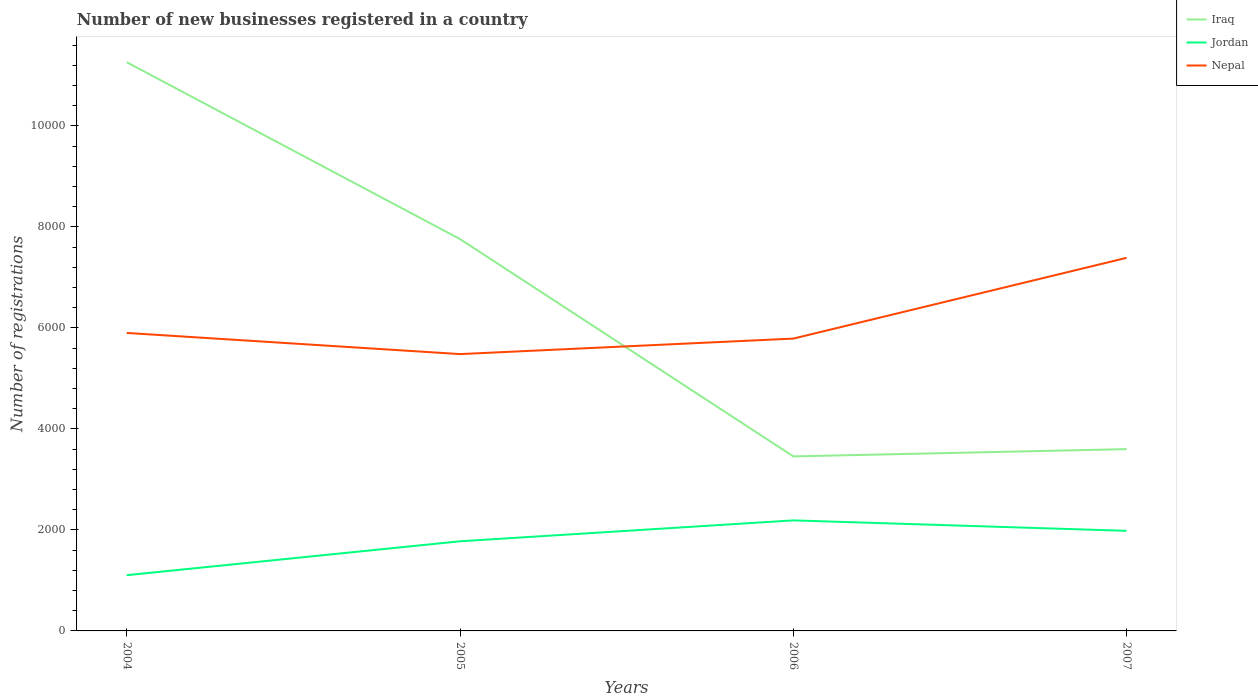Is the number of lines equal to the number of legend labels?
Provide a short and direct response. Yes. Across all years, what is the maximum number of new businesses registered in Jordan?
Provide a succinct answer. 1104. What is the total number of new businesses registered in Nepal in the graph?
Offer a very short reply. -307. What is the difference between the highest and the second highest number of new businesses registered in Nepal?
Give a very brief answer. 1906. How many years are there in the graph?
Make the answer very short. 4. What is the difference between two consecutive major ticks on the Y-axis?
Give a very brief answer. 2000. How many legend labels are there?
Provide a short and direct response. 3. What is the title of the graph?
Your answer should be very brief. Number of new businesses registered in a country. What is the label or title of the Y-axis?
Make the answer very short. Number of registrations. What is the Number of registrations in Iraq in 2004?
Your response must be concise. 1.13e+04. What is the Number of registrations of Jordan in 2004?
Provide a short and direct response. 1104. What is the Number of registrations in Nepal in 2004?
Your answer should be compact. 5901. What is the Number of registrations of Iraq in 2005?
Keep it short and to the point. 7760. What is the Number of registrations of Jordan in 2005?
Provide a short and direct response. 1775. What is the Number of registrations in Nepal in 2005?
Provide a succinct answer. 5482. What is the Number of registrations of Iraq in 2006?
Offer a very short reply. 3456. What is the Number of registrations of Jordan in 2006?
Keep it short and to the point. 2189. What is the Number of registrations of Nepal in 2006?
Your answer should be compact. 5789. What is the Number of registrations of Iraq in 2007?
Your response must be concise. 3600. What is the Number of registrations of Jordan in 2007?
Make the answer very short. 1982. What is the Number of registrations of Nepal in 2007?
Ensure brevity in your answer.  7388. Across all years, what is the maximum Number of registrations of Iraq?
Offer a terse response. 1.13e+04. Across all years, what is the maximum Number of registrations of Jordan?
Provide a short and direct response. 2189. Across all years, what is the maximum Number of registrations in Nepal?
Keep it short and to the point. 7388. Across all years, what is the minimum Number of registrations in Iraq?
Your response must be concise. 3456. Across all years, what is the minimum Number of registrations in Jordan?
Your answer should be very brief. 1104. Across all years, what is the minimum Number of registrations in Nepal?
Provide a short and direct response. 5482. What is the total Number of registrations in Iraq in the graph?
Provide a short and direct response. 2.61e+04. What is the total Number of registrations of Jordan in the graph?
Your answer should be compact. 7050. What is the total Number of registrations in Nepal in the graph?
Offer a very short reply. 2.46e+04. What is the difference between the Number of registrations of Iraq in 2004 and that in 2005?
Offer a very short reply. 3502. What is the difference between the Number of registrations of Jordan in 2004 and that in 2005?
Offer a very short reply. -671. What is the difference between the Number of registrations in Nepal in 2004 and that in 2005?
Provide a short and direct response. 419. What is the difference between the Number of registrations of Iraq in 2004 and that in 2006?
Offer a very short reply. 7806. What is the difference between the Number of registrations in Jordan in 2004 and that in 2006?
Offer a terse response. -1085. What is the difference between the Number of registrations in Nepal in 2004 and that in 2006?
Ensure brevity in your answer.  112. What is the difference between the Number of registrations in Iraq in 2004 and that in 2007?
Keep it short and to the point. 7662. What is the difference between the Number of registrations of Jordan in 2004 and that in 2007?
Offer a terse response. -878. What is the difference between the Number of registrations of Nepal in 2004 and that in 2007?
Ensure brevity in your answer.  -1487. What is the difference between the Number of registrations of Iraq in 2005 and that in 2006?
Keep it short and to the point. 4304. What is the difference between the Number of registrations in Jordan in 2005 and that in 2006?
Give a very brief answer. -414. What is the difference between the Number of registrations in Nepal in 2005 and that in 2006?
Provide a succinct answer. -307. What is the difference between the Number of registrations in Iraq in 2005 and that in 2007?
Ensure brevity in your answer.  4160. What is the difference between the Number of registrations in Jordan in 2005 and that in 2007?
Your answer should be very brief. -207. What is the difference between the Number of registrations in Nepal in 2005 and that in 2007?
Offer a terse response. -1906. What is the difference between the Number of registrations of Iraq in 2006 and that in 2007?
Give a very brief answer. -144. What is the difference between the Number of registrations in Jordan in 2006 and that in 2007?
Offer a terse response. 207. What is the difference between the Number of registrations in Nepal in 2006 and that in 2007?
Your answer should be compact. -1599. What is the difference between the Number of registrations in Iraq in 2004 and the Number of registrations in Jordan in 2005?
Ensure brevity in your answer.  9487. What is the difference between the Number of registrations in Iraq in 2004 and the Number of registrations in Nepal in 2005?
Make the answer very short. 5780. What is the difference between the Number of registrations in Jordan in 2004 and the Number of registrations in Nepal in 2005?
Keep it short and to the point. -4378. What is the difference between the Number of registrations in Iraq in 2004 and the Number of registrations in Jordan in 2006?
Keep it short and to the point. 9073. What is the difference between the Number of registrations of Iraq in 2004 and the Number of registrations of Nepal in 2006?
Give a very brief answer. 5473. What is the difference between the Number of registrations in Jordan in 2004 and the Number of registrations in Nepal in 2006?
Offer a very short reply. -4685. What is the difference between the Number of registrations in Iraq in 2004 and the Number of registrations in Jordan in 2007?
Your answer should be very brief. 9280. What is the difference between the Number of registrations of Iraq in 2004 and the Number of registrations of Nepal in 2007?
Keep it short and to the point. 3874. What is the difference between the Number of registrations of Jordan in 2004 and the Number of registrations of Nepal in 2007?
Offer a very short reply. -6284. What is the difference between the Number of registrations of Iraq in 2005 and the Number of registrations of Jordan in 2006?
Give a very brief answer. 5571. What is the difference between the Number of registrations in Iraq in 2005 and the Number of registrations in Nepal in 2006?
Your response must be concise. 1971. What is the difference between the Number of registrations in Jordan in 2005 and the Number of registrations in Nepal in 2006?
Offer a very short reply. -4014. What is the difference between the Number of registrations of Iraq in 2005 and the Number of registrations of Jordan in 2007?
Your answer should be compact. 5778. What is the difference between the Number of registrations in Iraq in 2005 and the Number of registrations in Nepal in 2007?
Keep it short and to the point. 372. What is the difference between the Number of registrations in Jordan in 2005 and the Number of registrations in Nepal in 2007?
Offer a very short reply. -5613. What is the difference between the Number of registrations in Iraq in 2006 and the Number of registrations in Jordan in 2007?
Provide a short and direct response. 1474. What is the difference between the Number of registrations in Iraq in 2006 and the Number of registrations in Nepal in 2007?
Your response must be concise. -3932. What is the difference between the Number of registrations of Jordan in 2006 and the Number of registrations of Nepal in 2007?
Make the answer very short. -5199. What is the average Number of registrations in Iraq per year?
Keep it short and to the point. 6519.5. What is the average Number of registrations of Jordan per year?
Offer a terse response. 1762.5. What is the average Number of registrations in Nepal per year?
Your answer should be compact. 6140. In the year 2004, what is the difference between the Number of registrations in Iraq and Number of registrations in Jordan?
Offer a very short reply. 1.02e+04. In the year 2004, what is the difference between the Number of registrations of Iraq and Number of registrations of Nepal?
Offer a very short reply. 5361. In the year 2004, what is the difference between the Number of registrations of Jordan and Number of registrations of Nepal?
Provide a succinct answer. -4797. In the year 2005, what is the difference between the Number of registrations in Iraq and Number of registrations in Jordan?
Provide a succinct answer. 5985. In the year 2005, what is the difference between the Number of registrations in Iraq and Number of registrations in Nepal?
Offer a terse response. 2278. In the year 2005, what is the difference between the Number of registrations of Jordan and Number of registrations of Nepal?
Your answer should be very brief. -3707. In the year 2006, what is the difference between the Number of registrations in Iraq and Number of registrations in Jordan?
Keep it short and to the point. 1267. In the year 2006, what is the difference between the Number of registrations of Iraq and Number of registrations of Nepal?
Keep it short and to the point. -2333. In the year 2006, what is the difference between the Number of registrations in Jordan and Number of registrations in Nepal?
Your answer should be compact. -3600. In the year 2007, what is the difference between the Number of registrations of Iraq and Number of registrations of Jordan?
Your answer should be very brief. 1618. In the year 2007, what is the difference between the Number of registrations in Iraq and Number of registrations in Nepal?
Offer a terse response. -3788. In the year 2007, what is the difference between the Number of registrations in Jordan and Number of registrations in Nepal?
Your answer should be very brief. -5406. What is the ratio of the Number of registrations of Iraq in 2004 to that in 2005?
Keep it short and to the point. 1.45. What is the ratio of the Number of registrations of Jordan in 2004 to that in 2005?
Make the answer very short. 0.62. What is the ratio of the Number of registrations in Nepal in 2004 to that in 2005?
Your answer should be very brief. 1.08. What is the ratio of the Number of registrations in Iraq in 2004 to that in 2006?
Provide a succinct answer. 3.26. What is the ratio of the Number of registrations in Jordan in 2004 to that in 2006?
Give a very brief answer. 0.5. What is the ratio of the Number of registrations in Nepal in 2004 to that in 2006?
Offer a very short reply. 1.02. What is the ratio of the Number of registrations of Iraq in 2004 to that in 2007?
Keep it short and to the point. 3.13. What is the ratio of the Number of registrations in Jordan in 2004 to that in 2007?
Provide a short and direct response. 0.56. What is the ratio of the Number of registrations in Nepal in 2004 to that in 2007?
Your answer should be very brief. 0.8. What is the ratio of the Number of registrations of Iraq in 2005 to that in 2006?
Provide a short and direct response. 2.25. What is the ratio of the Number of registrations in Jordan in 2005 to that in 2006?
Your response must be concise. 0.81. What is the ratio of the Number of registrations in Nepal in 2005 to that in 2006?
Your response must be concise. 0.95. What is the ratio of the Number of registrations of Iraq in 2005 to that in 2007?
Give a very brief answer. 2.16. What is the ratio of the Number of registrations of Jordan in 2005 to that in 2007?
Make the answer very short. 0.9. What is the ratio of the Number of registrations of Nepal in 2005 to that in 2007?
Provide a succinct answer. 0.74. What is the ratio of the Number of registrations of Jordan in 2006 to that in 2007?
Offer a very short reply. 1.1. What is the ratio of the Number of registrations of Nepal in 2006 to that in 2007?
Offer a very short reply. 0.78. What is the difference between the highest and the second highest Number of registrations of Iraq?
Ensure brevity in your answer.  3502. What is the difference between the highest and the second highest Number of registrations of Jordan?
Your response must be concise. 207. What is the difference between the highest and the second highest Number of registrations in Nepal?
Offer a very short reply. 1487. What is the difference between the highest and the lowest Number of registrations in Iraq?
Keep it short and to the point. 7806. What is the difference between the highest and the lowest Number of registrations of Jordan?
Make the answer very short. 1085. What is the difference between the highest and the lowest Number of registrations in Nepal?
Provide a succinct answer. 1906. 